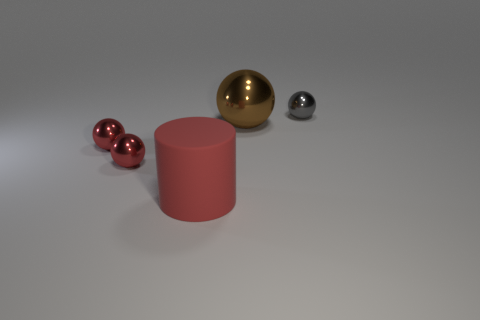Add 4 small shiny balls. How many objects exist? 9 Subtract all cylinders. How many objects are left? 4 Subtract 0 blue blocks. How many objects are left? 5 Subtract all large red rubber objects. Subtract all metal balls. How many objects are left? 0 Add 5 brown shiny spheres. How many brown shiny spheres are left? 6 Add 5 red balls. How many red balls exist? 7 